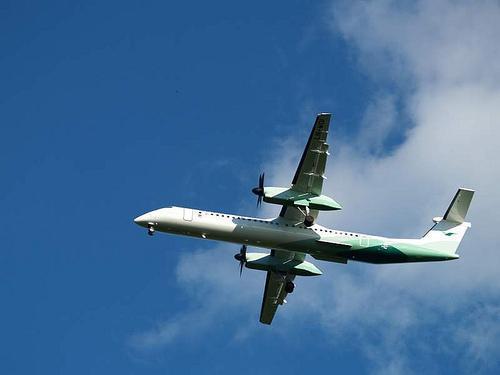How many planes are there?
Give a very brief answer. 1. 